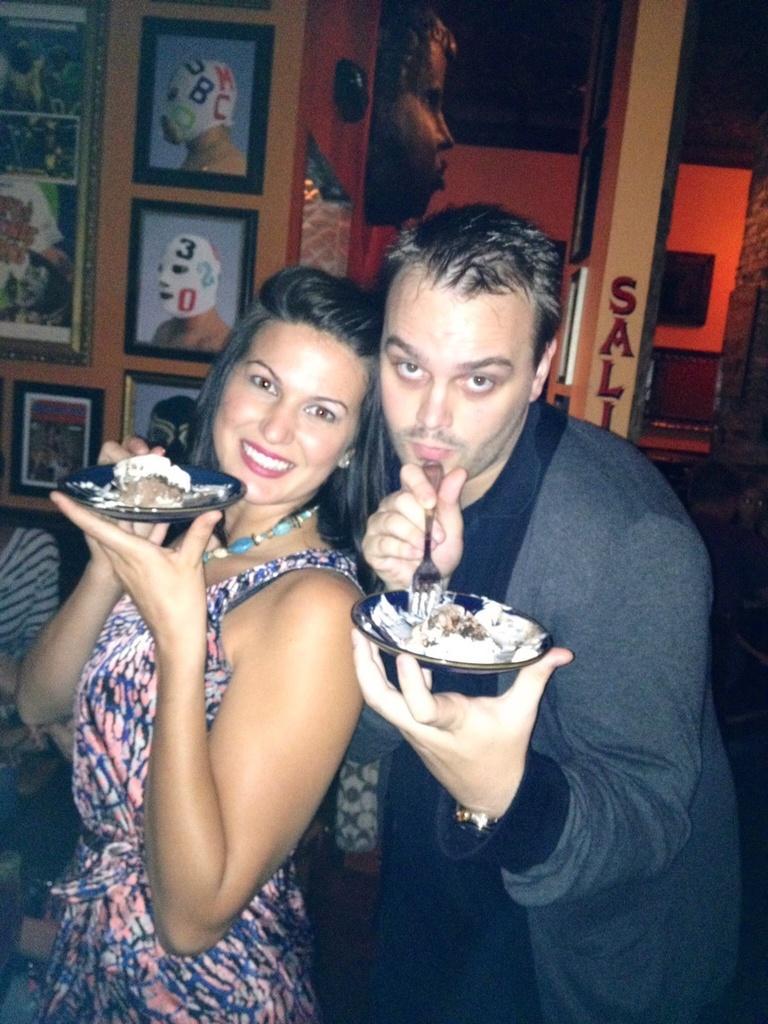Could you give a brief overview of what you see in this image? In this image there is a couple who are holding the plates. In the plates there is an ice cream. In the background there is a wall on which there are photo frames. Beside the frames there is a statue of a face. On the left side there are few other people sitting in the sofa. On the right side there is a wall on which there is some text. In the background there is a television which is attached to the wall. 